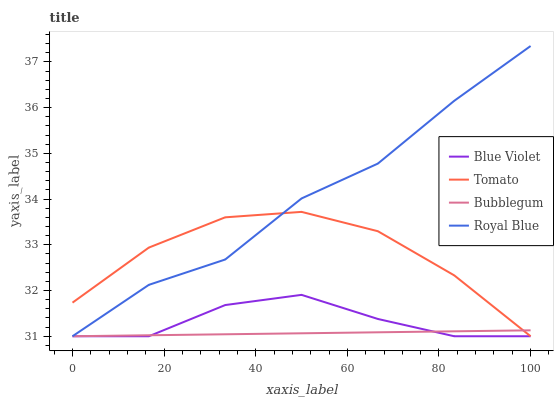Does Royal Blue have the minimum area under the curve?
Answer yes or no. No. Does Bubblegum have the maximum area under the curve?
Answer yes or no. No. Is Royal Blue the smoothest?
Answer yes or no. No. Is Bubblegum the roughest?
Answer yes or no. No. Does Bubblegum have the highest value?
Answer yes or no. No. 